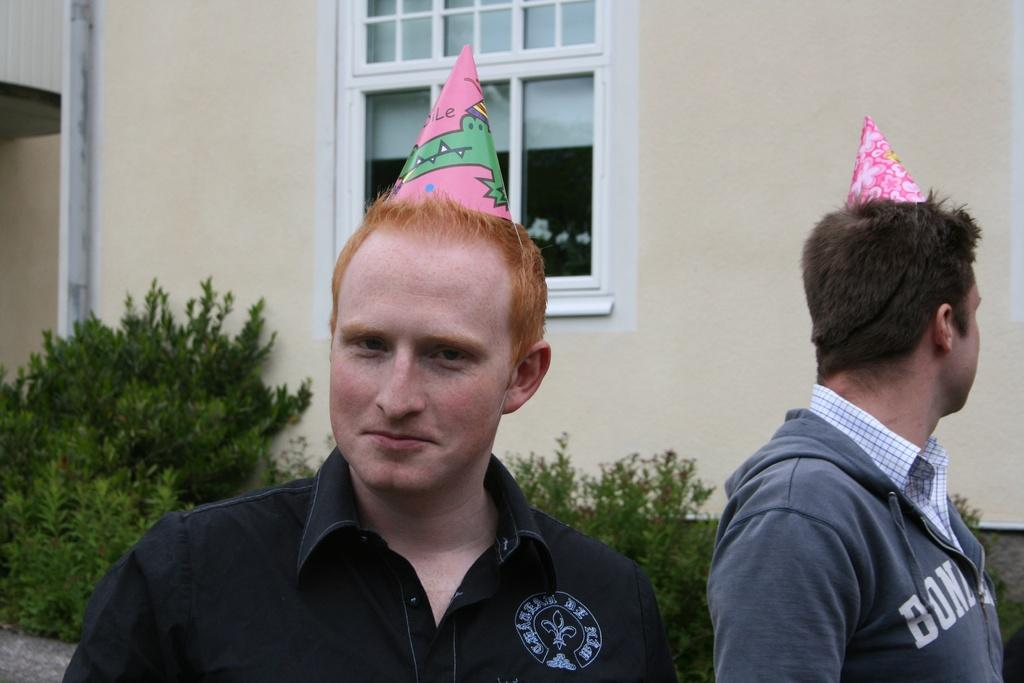Who is present in the image? There are men in the image. What are the men wearing on their heads? The men are wearing birthday caps. What can be seen in the background of the image? There are windows, walls, and plants in the background of the image. How many years has the men's aunt been in authority? There is no mention of an aunt or authority in the image, so this question cannot be answered. 